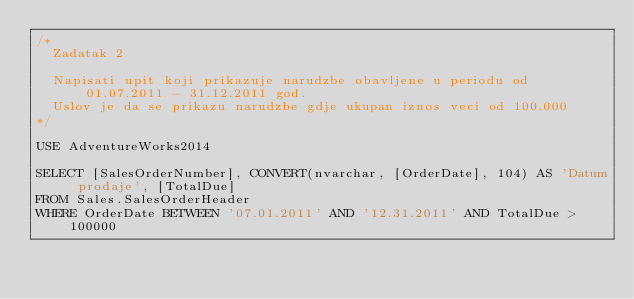<code> <loc_0><loc_0><loc_500><loc_500><_SQL_>/*
	Zadatak 2

	Napisati upit koji prikazuje narudzbe obavljene u periodu od 01.07.2011 - 31.12.2011 god.
	Uslov je da se prikazu narudzbe gdje ukupan iznos veci od 100.000
*/

USE AdventureWorks2014

SELECT [SalesOrderNumber], CONVERT(nvarchar, [OrderDate], 104) AS 'Datum prodaje', [TotalDue]
FROM Sales.SalesOrderHeader
WHERE OrderDate BETWEEN '07.01.2011' AND '12.31.2011' AND TotalDue > 100000</code> 